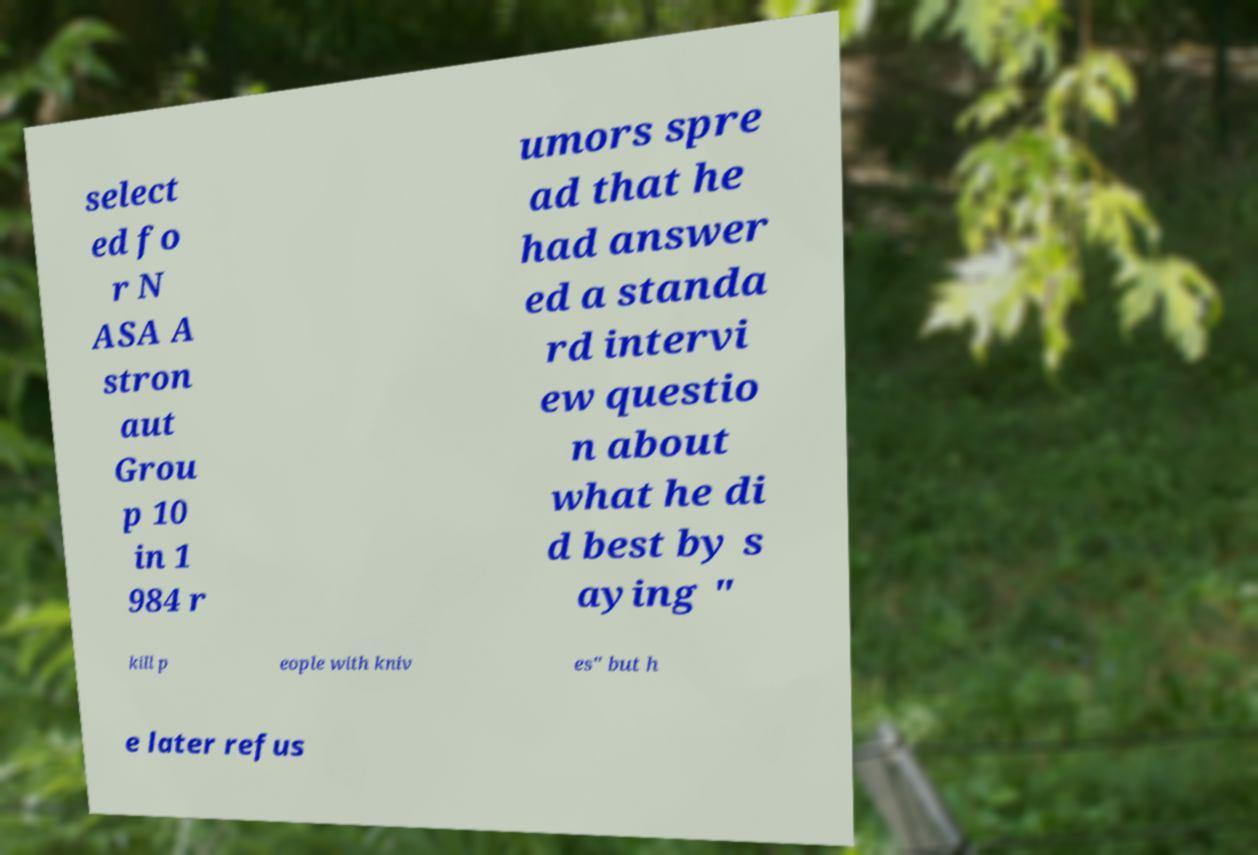Please identify and transcribe the text found in this image. select ed fo r N ASA A stron aut Grou p 10 in 1 984 r umors spre ad that he had answer ed a standa rd intervi ew questio n about what he di d best by s aying " kill p eople with kniv es" but h e later refus 